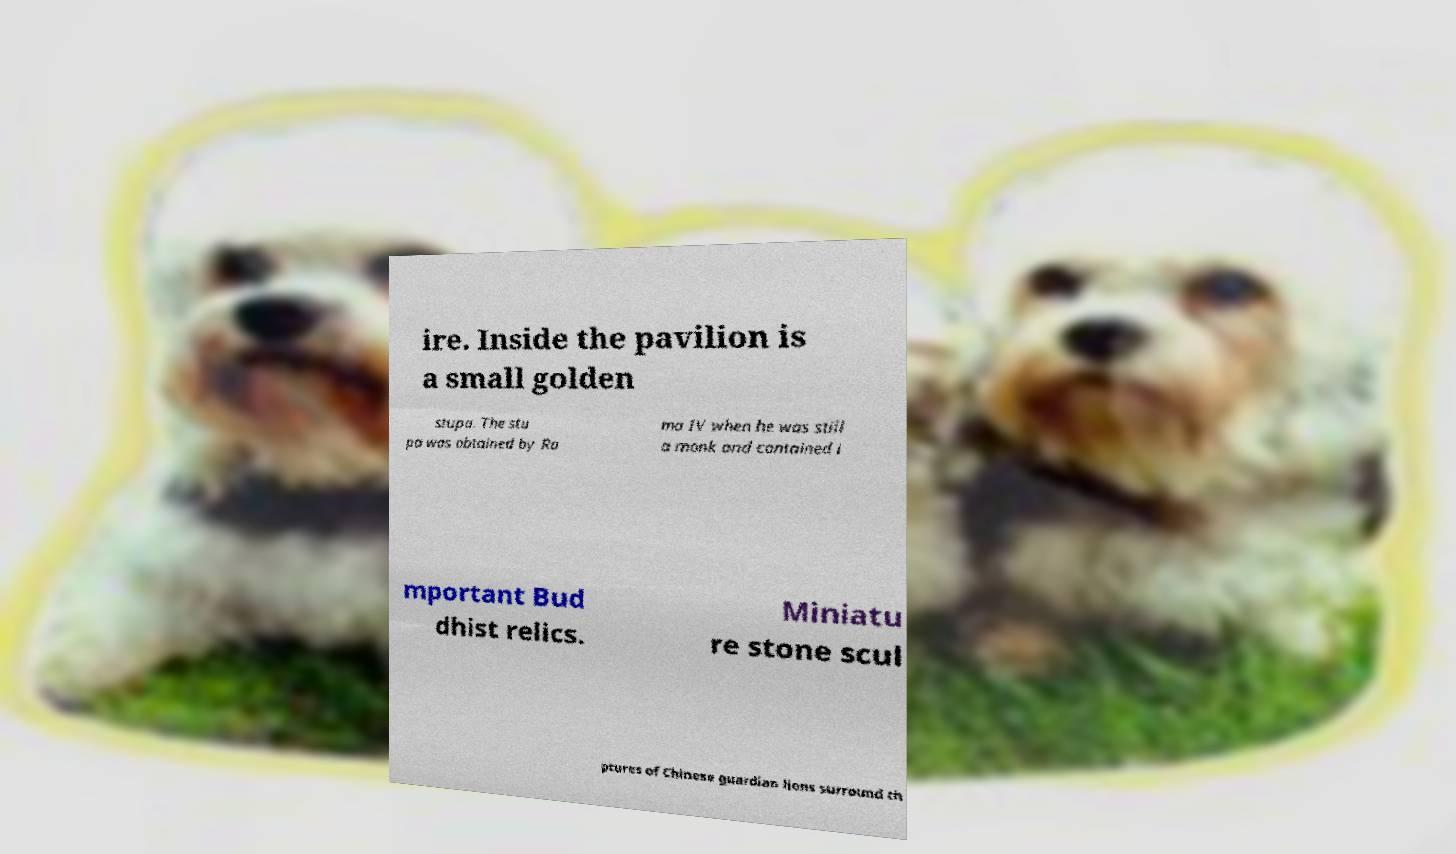What messages or text are displayed in this image? I need them in a readable, typed format. ire. Inside the pavilion is a small golden stupa. The stu pa was obtained by Ra ma IV when he was still a monk and contained i mportant Bud dhist relics. Miniatu re stone scul ptures of Chinese guardian lions surround th 